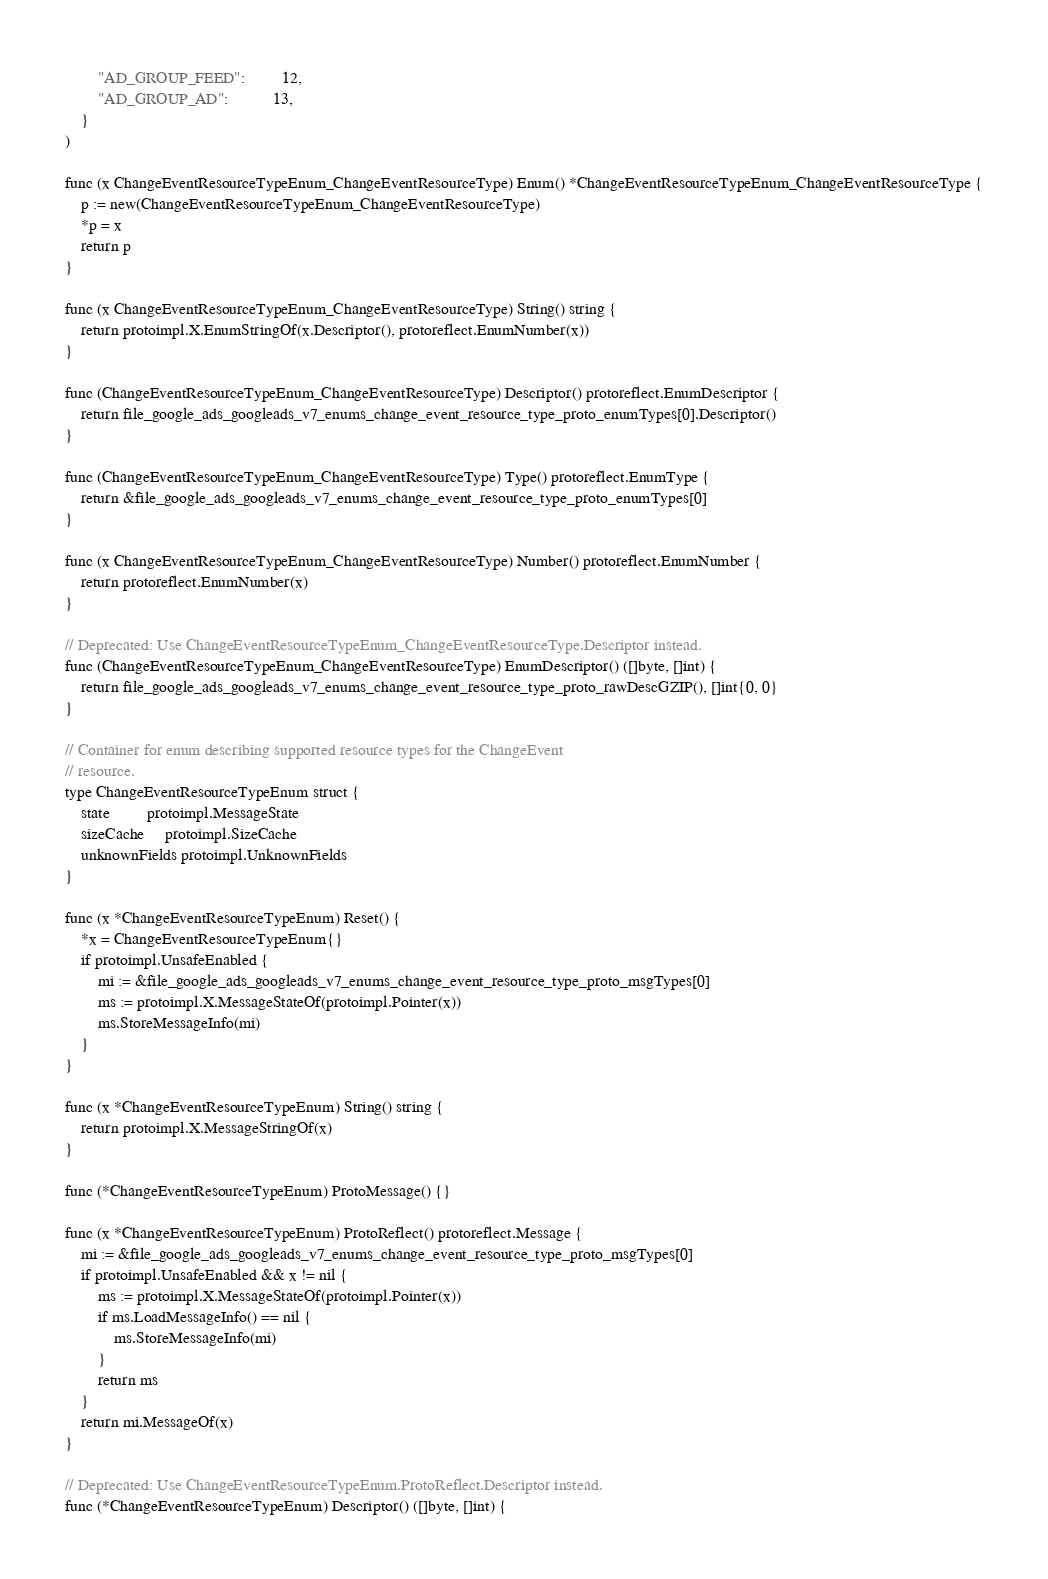<code> <loc_0><loc_0><loc_500><loc_500><_Go_>		"AD_GROUP_FEED":         12,
		"AD_GROUP_AD":           13,
	}
)

func (x ChangeEventResourceTypeEnum_ChangeEventResourceType) Enum() *ChangeEventResourceTypeEnum_ChangeEventResourceType {
	p := new(ChangeEventResourceTypeEnum_ChangeEventResourceType)
	*p = x
	return p
}

func (x ChangeEventResourceTypeEnum_ChangeEventResourceType) String() string {
	return protoimpl.X.EnumStringOf(x.Descriptor(), protoreflect.EnumNumber(x))
}

func (ChangeEventResourceTypeEnum_ChangeEventResourceType) Descriptor() protoreflect.EnumDescriptor {
	return file_google_ads_googleads_v7_enums_change_event_resource_type_proto_enumTypes[0].Descriptor()
}

func (ChangeEventResourceTypeEnum_ChangeEventResourceType) Type() protoreflect.EnumType {
	return &file_google_ads_googleads_v7_enums_change_event_resource_type_proto_enumTypes[0]
}

func (x ChangeEventResourceTypeEnum_ChangeEventResourceType) Number() protoreflect.EnumNumber {
	return protoreflect.EnumNumber(x)
}

// Deprecated: Use ChangeEventResourceTypeEnum_ChangeEventResourceType.Descriptor instead.
func (ChangeEventResourceTypeEnum_ChangeEventResourceType) EnumDescriptor() ([]byte, []int) {
	return file_google_ads_googleads_v7_enums_change_event_resource_type_proto_rawDescGZIP(), []int{0, 0}
}

// Container for enum describing supported resource types for the ChangeEvent
// resource.
type ChangeEventResourceTypeEnum struct {
	state         protoimpl.MessageState
	sizeCache     protoimpl.SizeCache
	unknownFields protoimpl.UnknownFields
}

func (x *ChangeEventResourceTypeEnum) Reset() {
	*x = ChangeEventResourceTypeEnum{}
	if protoimpl.UnsafeEnabled {
		mi := &file_google_ads_googleads_v7_enums_change_event_resource_type_proto_msgTypes[0]
		ms := protoimpl.X.MessageStateOf(protoimpl.Pointer(x))
		ms.StoreMessageInfo(mi)
	}
}

func (x *ChangeEventResourceTypeEnum) String() string {
	return protoimpl.X.MessageStringOf(x)
}

func (*ChangeEventResourceTypeEnum) ProtoMessage() {}

func (x *ChangeEventResourceTypeEnum) ProtoReflect() protoreflect.Message {
	mi := &file_google_ads_googleads_v7_enums_change_event_resource_type_proto_msgTypes[0]
	if protoimpl.UnsafeEnabled && x != nil {
		ms := protoimpl.X.MessageStateOf(protoimpl.Pointer(x))
		if ms.LoadMessageInfo() == nil {
			ms.StoreMessageInfo(mi)
		}
		return ms
	}
	return mi.MessageOf(x)
}

// Deprecated: Use ChangeEventResourceTypeEnum.ProtoReflect.Descriptor instead.
func (*ChangeEventResourceTypeEnum) Descriptor() ([]byte, []int) {</code> 